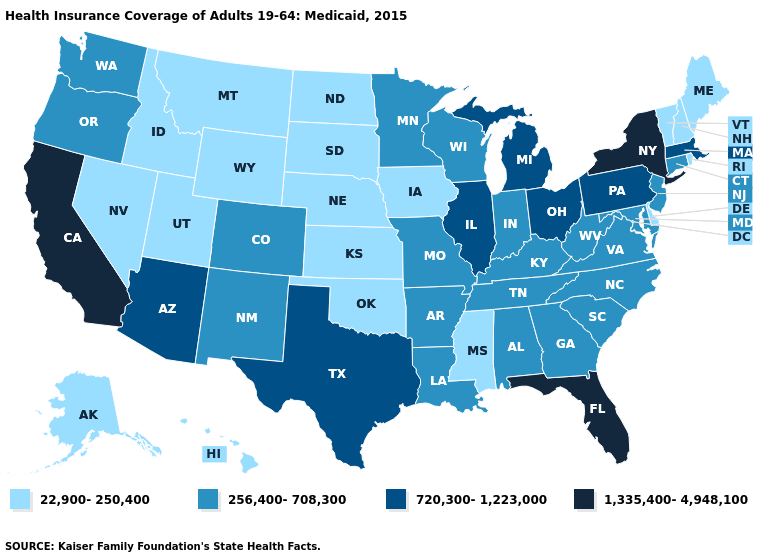Name the states that have a value in the range 1,335,400-4,948,100?
Quick response, please. California, Florida, New York. Name the states that have a value in the range 720,300-1,223,000?
Quick response, please. Arizona, Illinois, Massachusetts, Michigan, Ohio, Pennsylvania, Texas. Among the states that border South Dakota , does Nebraska have the highest value?
Keep it brief. No. Among the states that border Massachusetts , which have the lowest value?
Be succinct. New Hampshire, Rhode Island, Vermont. What is the highest value in the MidWest ?
Be succinct. 720,300-1,223,000. Name the states that have a value in the range 720,300-1,223,000?
Concise answer only. Arizona, Illinois, Massachusetts, Michigan, Ohio, Pennsylvania, Texas. Which states have the lowest value in the West?
Keep it brief. Alaska, Hawaii, Idaho, Montana, Nevada, Utah, Wyoming. Does the first symbol in the legend represent the smallest category?
Quick response, please. Yes. Does Colorado have the lowest value in the West?
Write a very short answer. No. What is the value of Michigan?
Concise answer only. 720,300-1,223,000. Does Kentucky have the highest value in the South?
Quick response, please. No. Name the states that have a value in the range 1,335,400-4,948,100?
Write a very short answer. California, Florida, New York. What is the value of Washington?
Short answer required. 256,400-708,300. Does Texas have the same value as Pennsylvania?
Answer briefly. Yes. Which states hav the highest value in the MidWest?
Quick response, please. Illinois, Michigan, Ohio. 